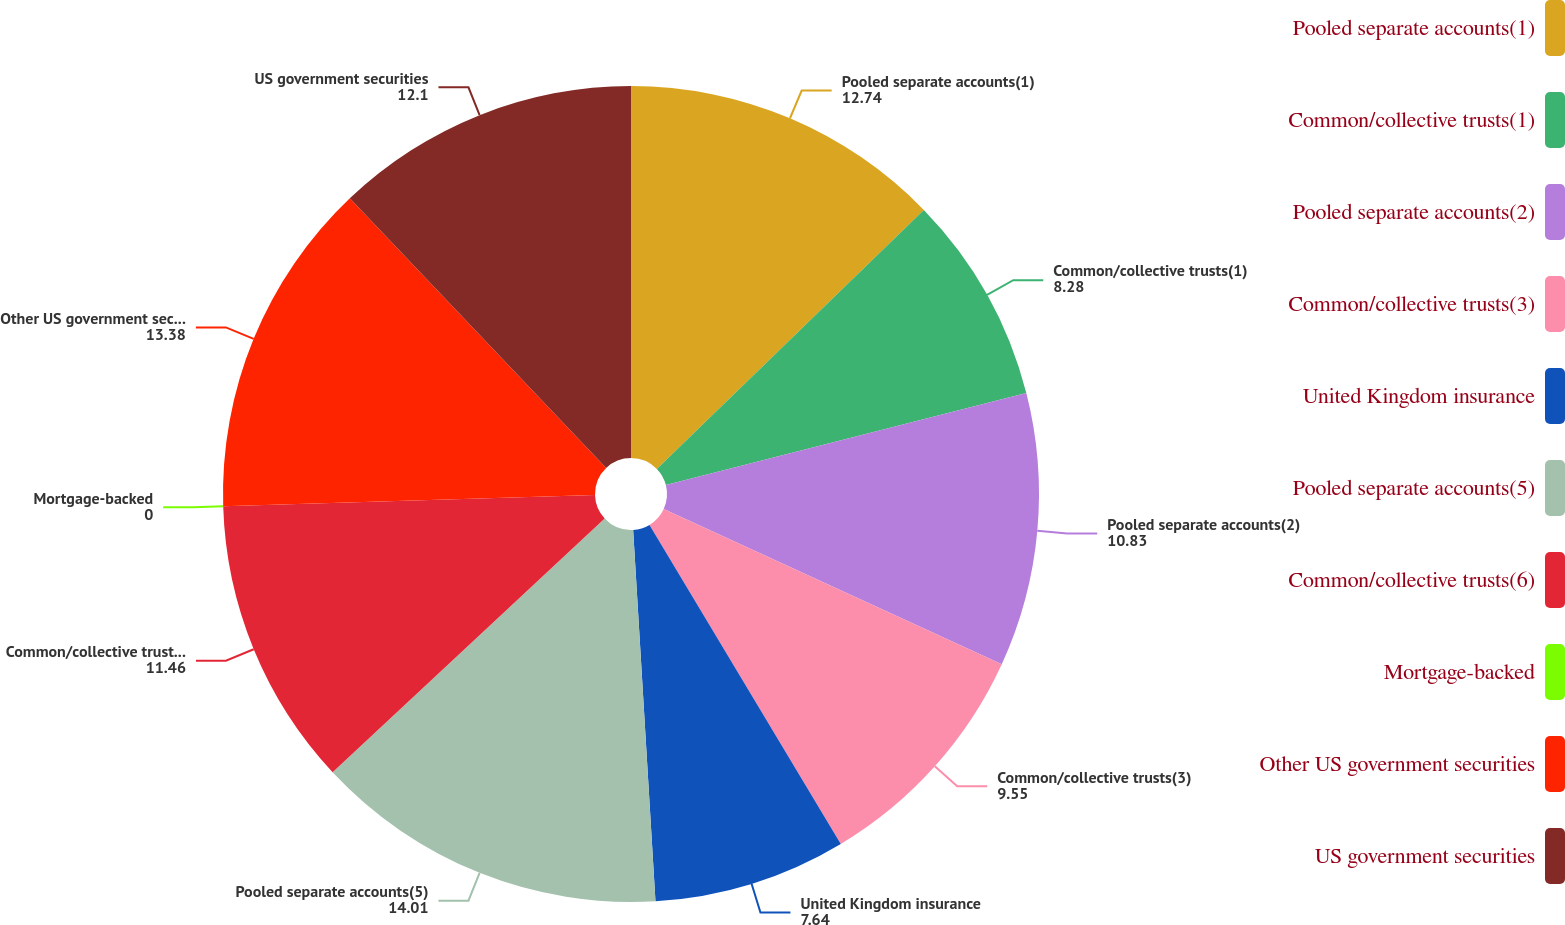<chart> <loc_0><loc_0><loc_500><loc_500><pie_chart><fcel>Pooled separate accounts(1)<fcel>Common/collective trusts(1)<fcel>Pooled separate accounts(2)<fcel>Common/collective trusts(3)<fcel>United Kingdom insurance<fcel>Pooled separate accounts(5)<fcel>Common/collective trusts(6)<fcel>Mortgage-backed<fcel>Other US government securities<fcel>US government securities<nl><fcel>12.74%<fcel>8.28%<fcel>10.83%<fcel>9.55%<fcel>7.64%<fcel>14.01%<fcel>11.46%<fcel>0.0%<fcel>13.38%<fcel>12.1%<nl></chart> 